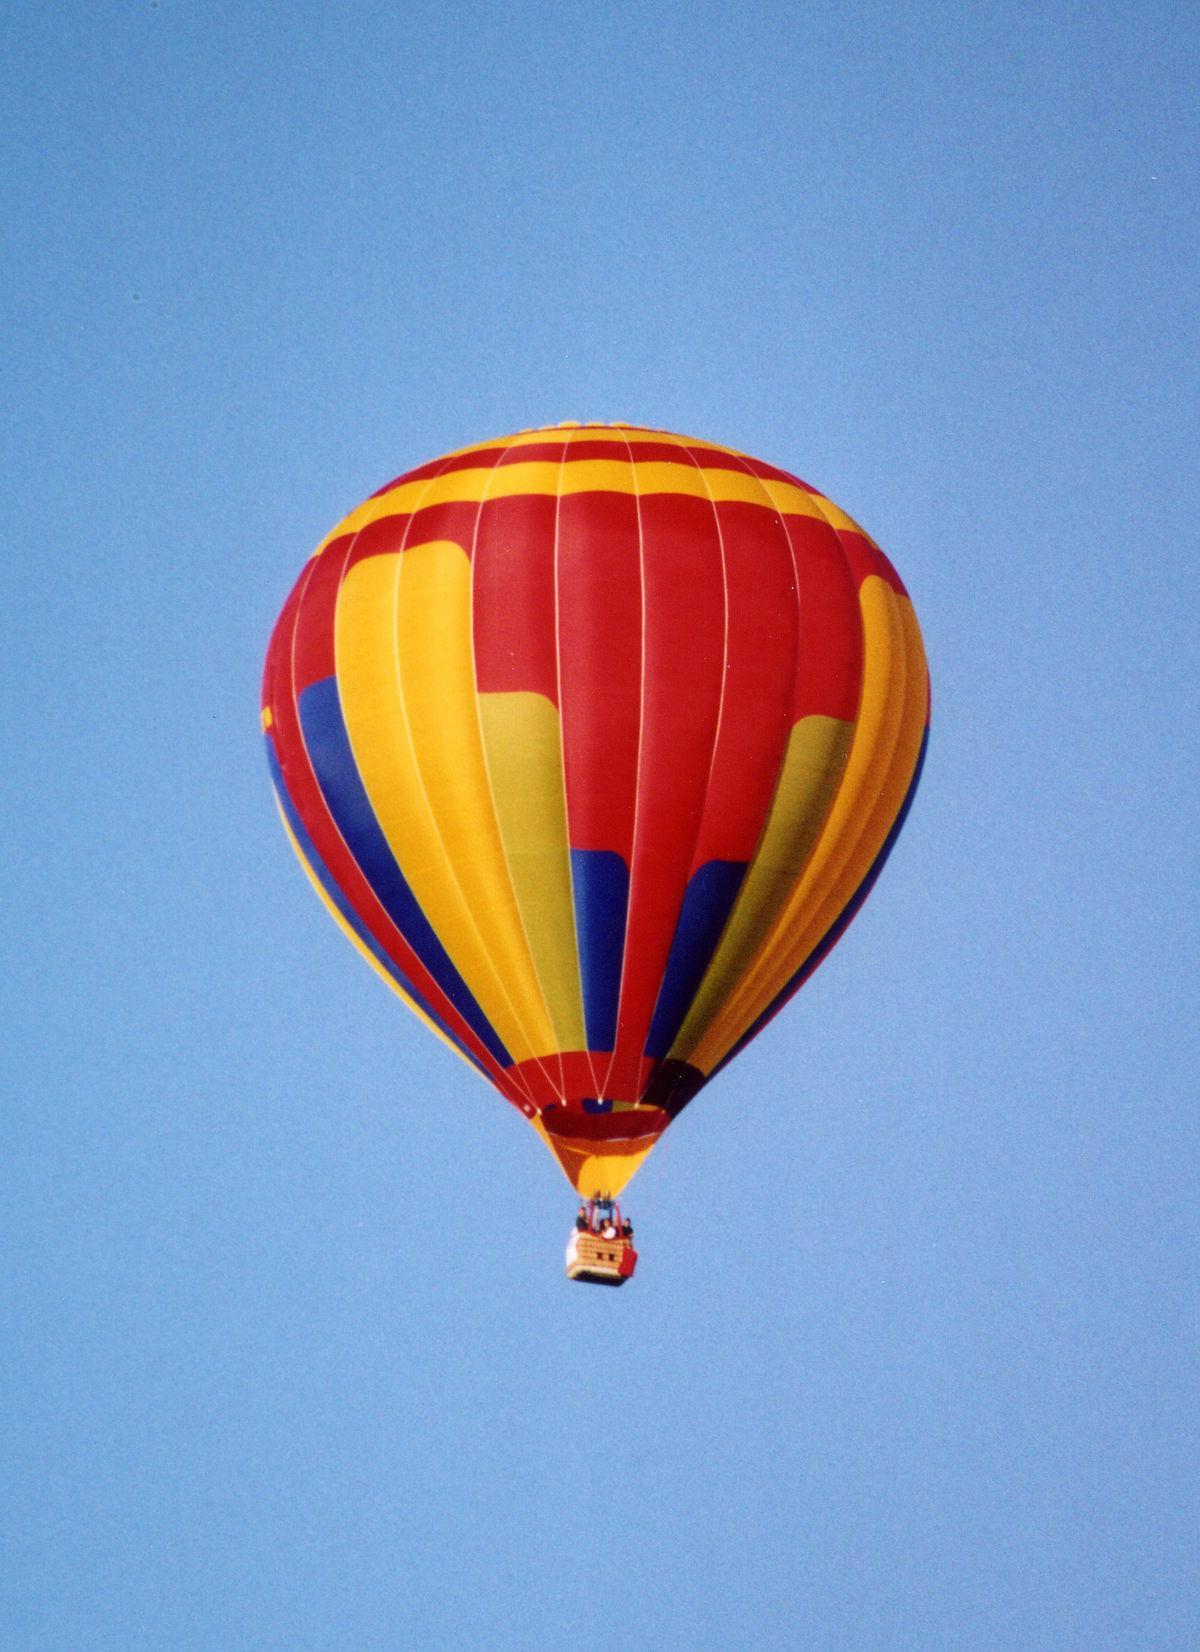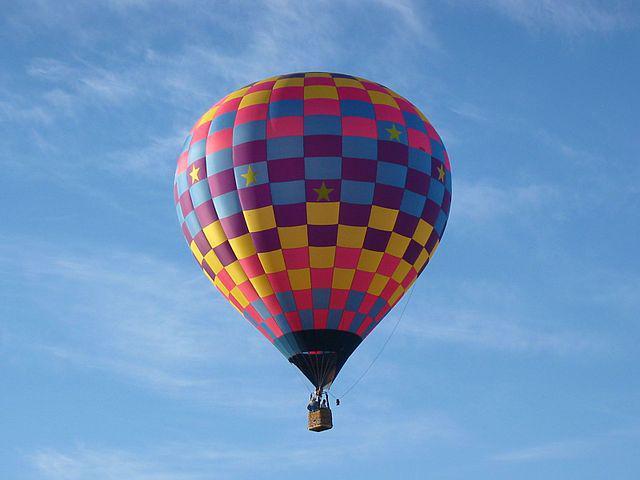The first image is the image on the left, the second image is the image on the right. Examine the images to the left and right. Is the description "Right image features exactly one balloon, which is decorated with checkerboard pattern." accurate? Answer yes or no. Yes. The first image is the image on the left, the second image is the image on the right. Assess this claim about the two images: "There is a rope that runs from the right side of the basket up to the balloon in the image on the left.". Correct or not? Answer yes or no. No. 